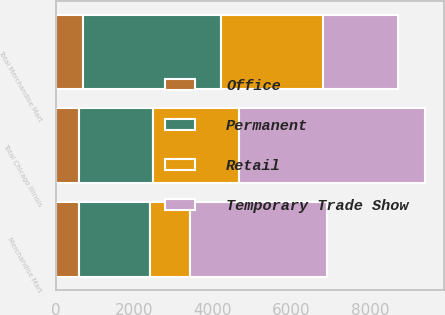Convert chart. <chart><loc_0><loc_0><loc_500><loc_500><stacked_bar_chart><ecel><fcel>Merchandise Mart<fcel>Total Chicago Illinois<fcel>Total Merchandise Mart<nl><fcel>Temporary Trade Show<fcel>3492<fcel>4744<fcel>1893<nl><fcel>Retail<fcel>1033<fcel>2192<fcel>2608<nl><fcel>Permanent<fcel>1810<fcel>1893<fcel>3521<nl><fcel>Office<fcel>582<fcel>582<fcel>683<nl></chart> 